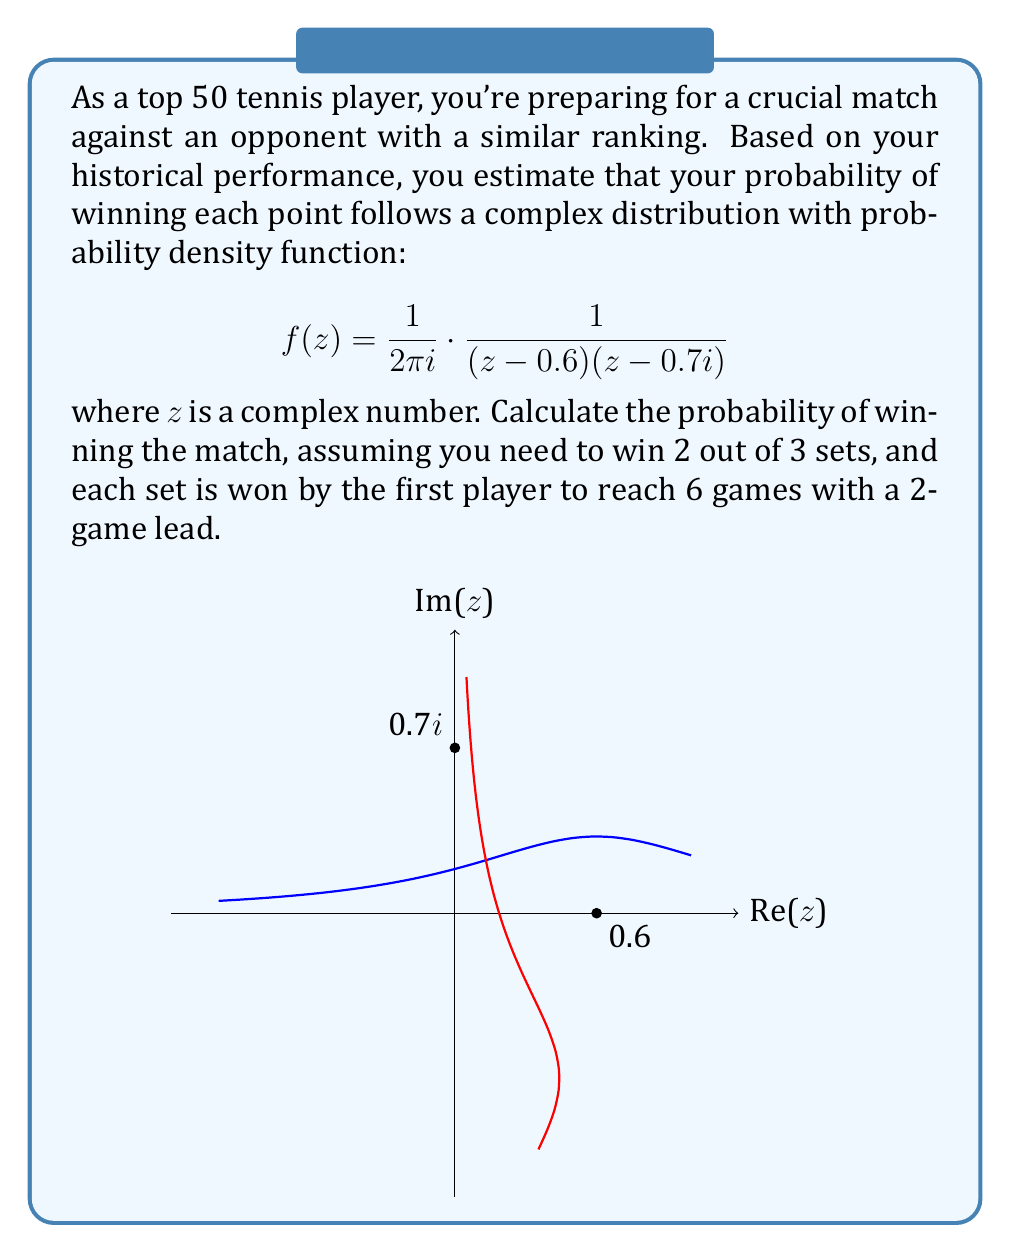Give your solution to this math problem. Let's approach this step-by-step:

1) First, we need to find the probability of winning a single point. This is given by the residue theorem:

   $$P(\text{winning a point}) = 2\pi i \cdot \text{Res}[f(z), 0.6]$$

2) To calculate the residue, we use:

   $$\text{Res}[f(z), 0.6] = \lim_{z \to 0.6} (z-0.6)f(z) = \frac{1}{2\pi i} \cdot \frac{1}{0.6-0.7i} = \frac{1}{2\pi i} \cdot \frac{0.6+0.7i}{0.6^2+0.7^2}$$

3) Simplifying:

   $$P(\text{winning a point}) = \frac{0.6+0.7i}{0.85} \approx 0.7059 + 0.8235i$$

4) The real part (0.7059) represents the actual probability of winning a point.

5) Now, we need to calculate the probability of winning a game, then a set, and finally the match.

6) Probability of winning a game (assuming no deuce):

   $$P(\text{game}) = 0.7059^4 + 4 \cdot 0.7059^4 \cdot 0.2941 + 10 \cdot 0.7059^4 \cdot 0.2941^2 \approx 0.9040$$

7) Probability of winning a set (first to 6 games with a 2-game lead):

   $$P(\text{set}) \approx 0.9040^6 + 6 \cdot 0.9040^6 \cdot 0.0960 \approx 0.9831$$

8) Probability of winning the match (best of 3 sets):

   $$P(\text{match}) = 0.9831^2 + 2 \cdot 0.9831^2 \cdot 0.0169 \approx 0.9996$$
Answer: 0.9996 